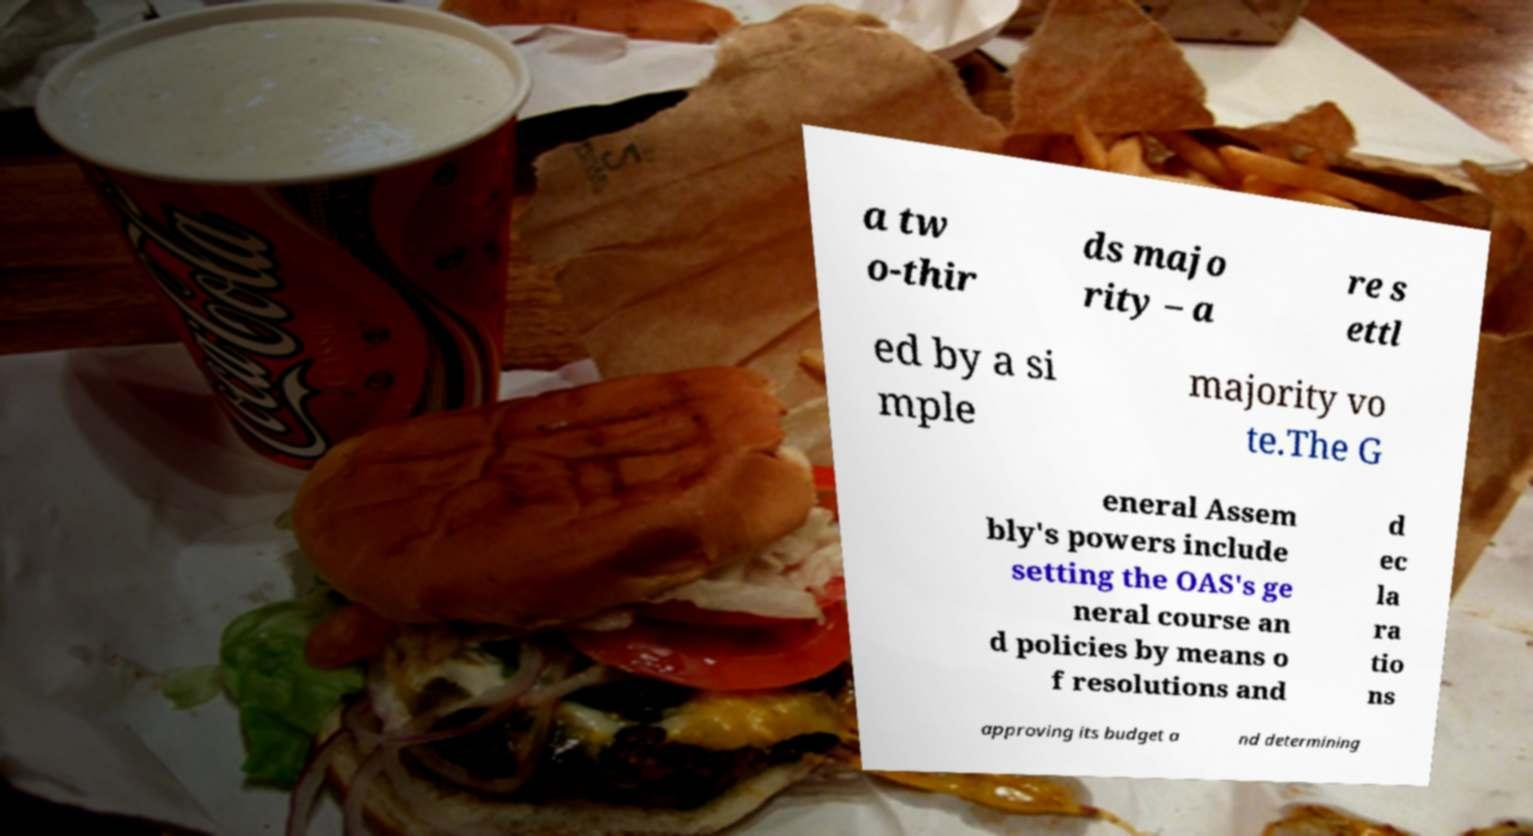Please read and relay the text visible in this image. What does it say? a tw o-thir ds majo rity – a re s ettl ed by a si mple majority vo te.The G eneral Assem bly's powers include setting the OAS's ge neral course an d policies by means o f resolutions and d ec la ra tio ns approving its budget a nd determining 